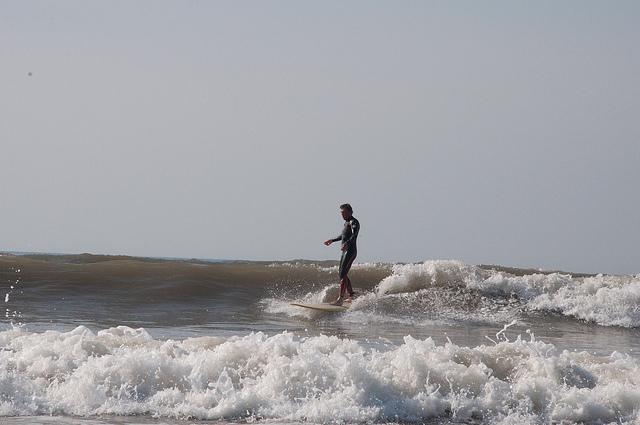How many birds are in the photo?
Give a very brief answer. 0. 